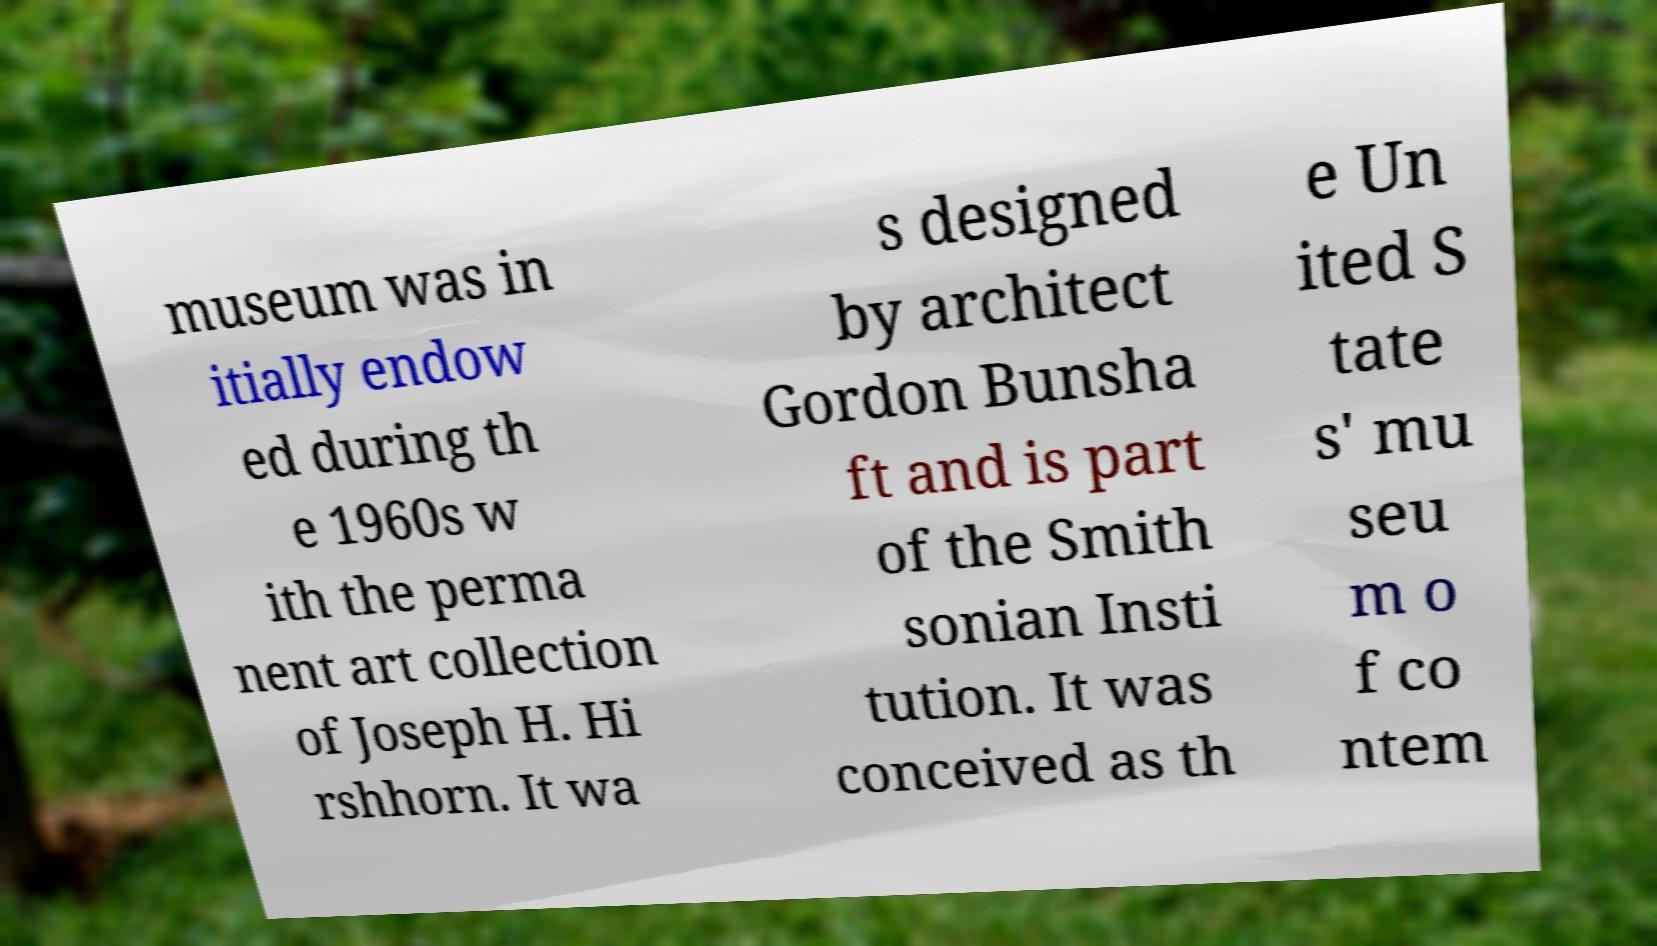Please read and relay the text visible in this image. What does it say? museum was in itially endow ed during th e 1960s w ith the perma nent art collection of Joseph H. Hi rshhorn. It wa s designed by architect Gordon Bunsha ft and is part of the Smith sonian Insti tution. It was conceived as th e Un ited S tate s' mu seu m o f co ntem 